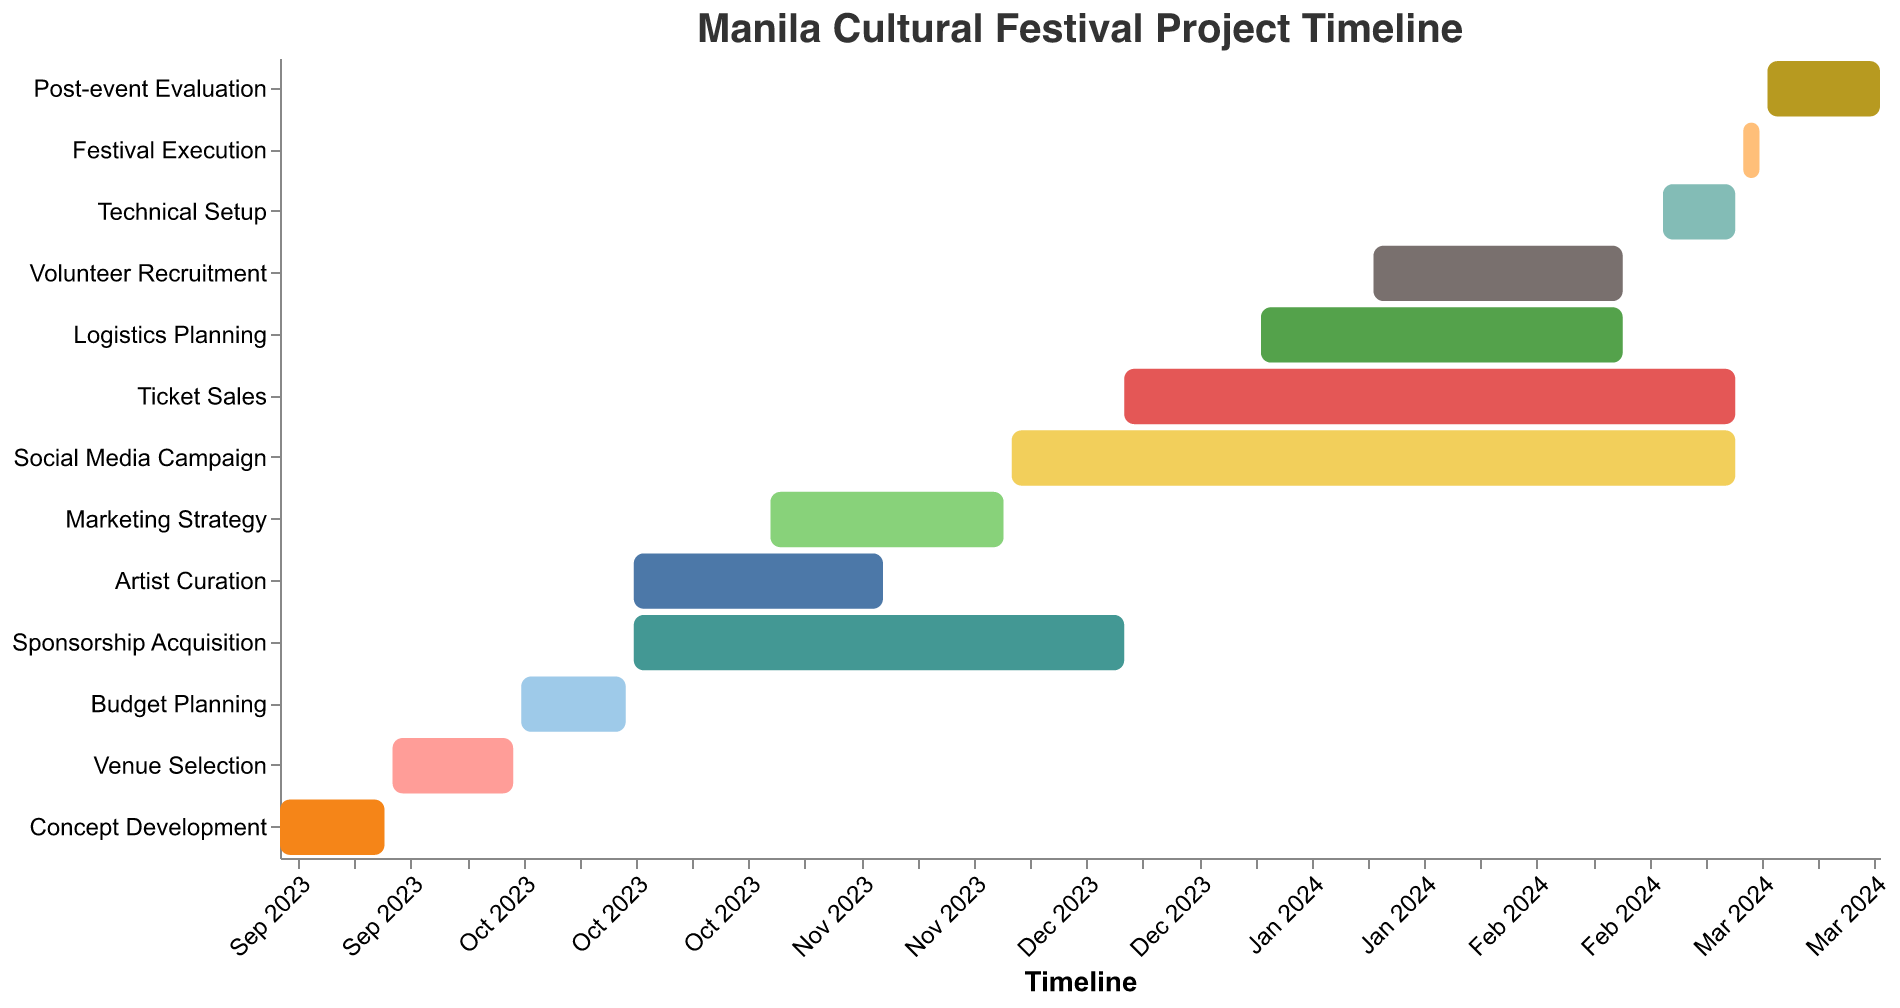What's the title of the chart? The title is displayed at the top of the chart.
Answer: Manila Cultural Festival Project Timeline What are the start and end dates for the "Venue Selection" phase? Check the "Venue Selection" bar on the chart and note the dates at the start and end points of the bar.
Answer: 2023-09-15 to 2023-09-30 Which task has the longest duration? Look for the bar with the longest length on the chart.
Answer: Social Media Campaign Which two tasks start on the same date? Identify bars that begin from the same point on the timeline axis.
Answer: Artist Curation and Sponsorship Acquisition What is the duration of the "Festival Execution" phase? Check the duration specified on the tooltip or by calculating the difference between the start and end dates for the "Festival Execution" bar.
Answer: 3 days How many days does the "Technical Setup" phase last? Check the duration specified on the tooltip or by calculating the difference between the start and end dates for the "Technical Setup" bar.
Answer: 10 days Which task ends first in the entire project timeline? Look for the bar with the earliest end date on the timeline axis.
Answer: Concept Development Which phase starts immediately after "Budget Planning"? Locate the end date of "Budget Planning" and find the next task that starts right after this date.
Answer: Artist Curation Among "Logistics Planning" and "Volunteer Recruitment," which one starts later? Compare the start dates of both tasks on the timeline axis.
Answer: Volunteer Recruitment Sum the total days for "Sponsorship Acquisition" and "Marketing Strategy" phases. Add the durations of both phases: 62 days from "Sponsorship Acquisition" and 30 days from "Marketing Strategy." 62 + 30 = 92
Answer: 92 days When does the "Post-event Evaluation" begin? Identify the start date by checking the bar for "Post-event Evaluation" on the timeline axis.
Answer: 2024-03-04 